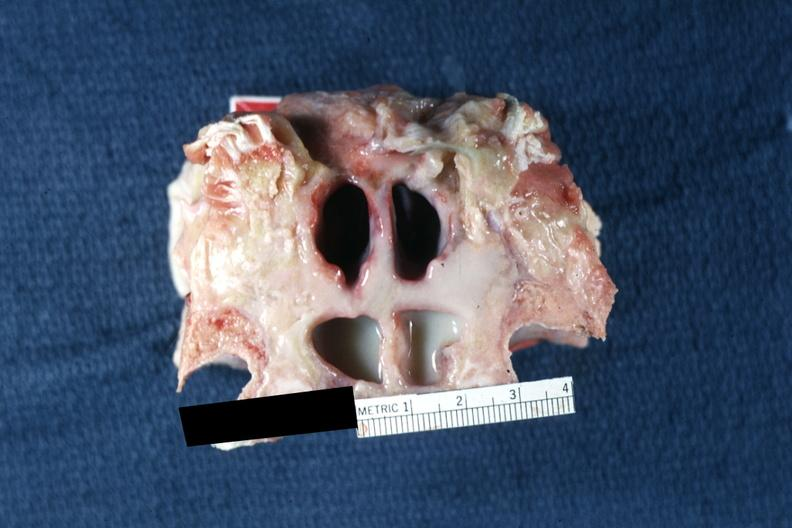s carcinomatosis endometrium primary present?
Answer the question using a single word or phrase. No 